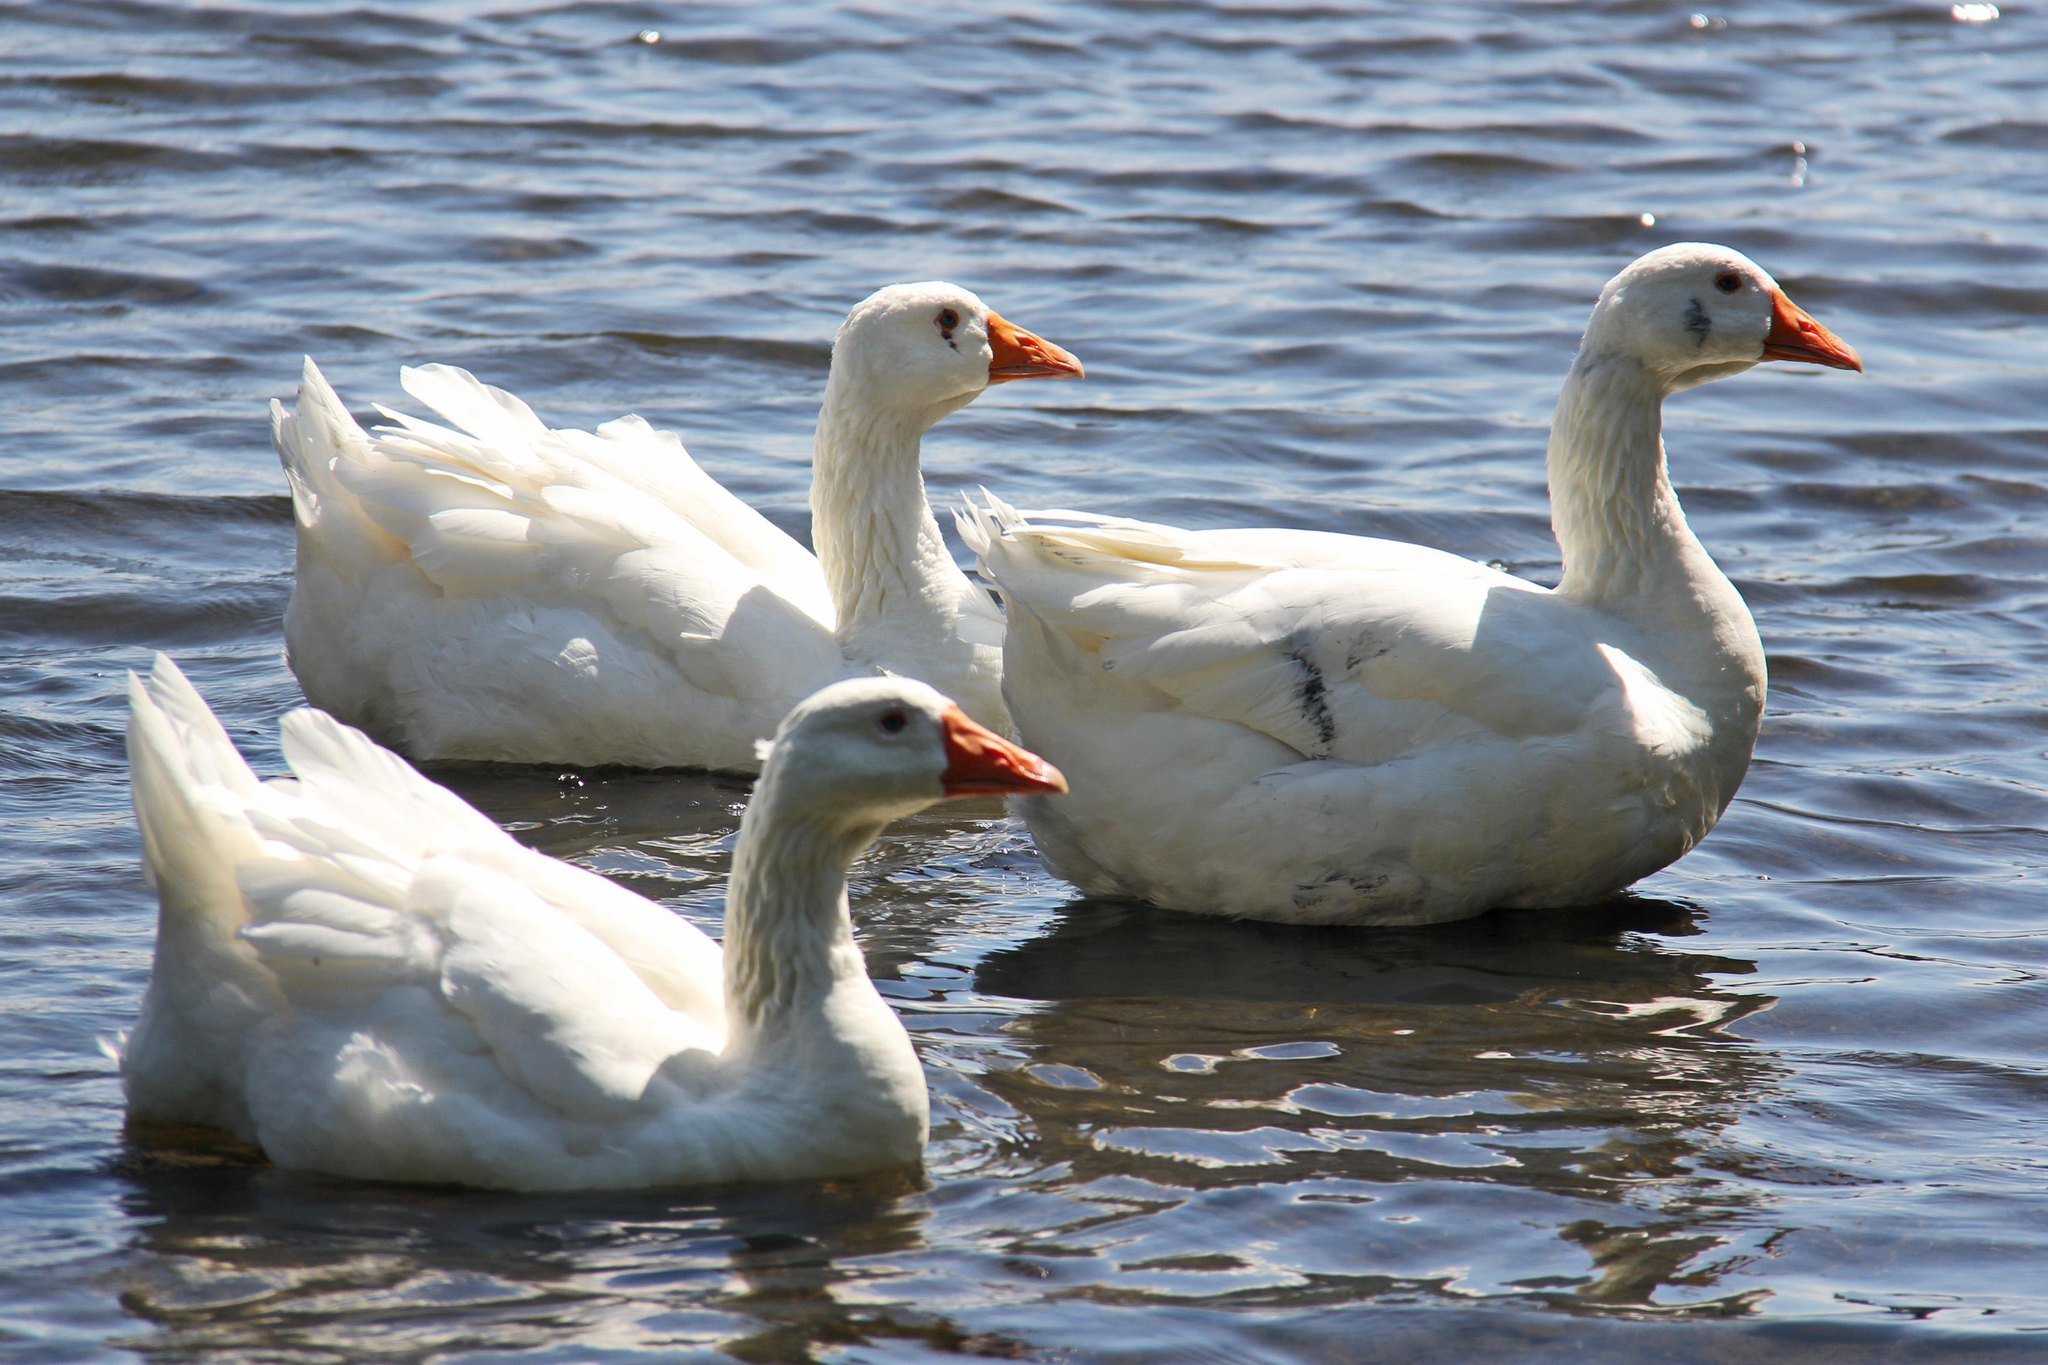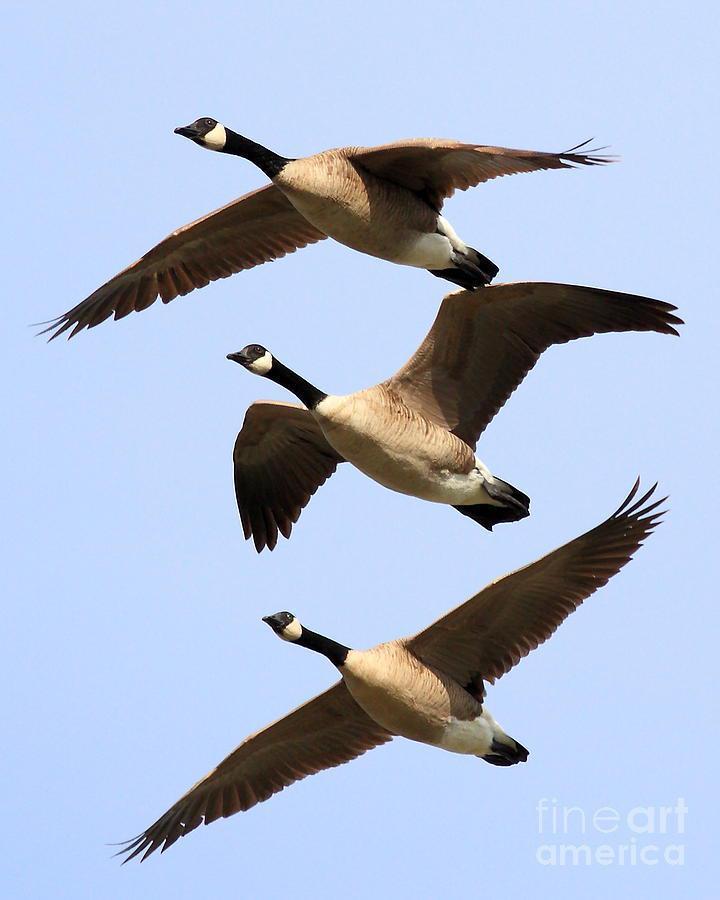The first image is the image on the left, the second image is the image on the right. Examine the images to the left and right. Is the description "In the left image, three geese with orange beaks are floating on water" accurate? Answer yes or no. Yes. The first image is the image on the left, the second image is the image on the right. Given the left and right images, does the statement "Three birds float on a pool of water and none of them face leftward, in one image." hold true? Answer yes or no. Yes. 